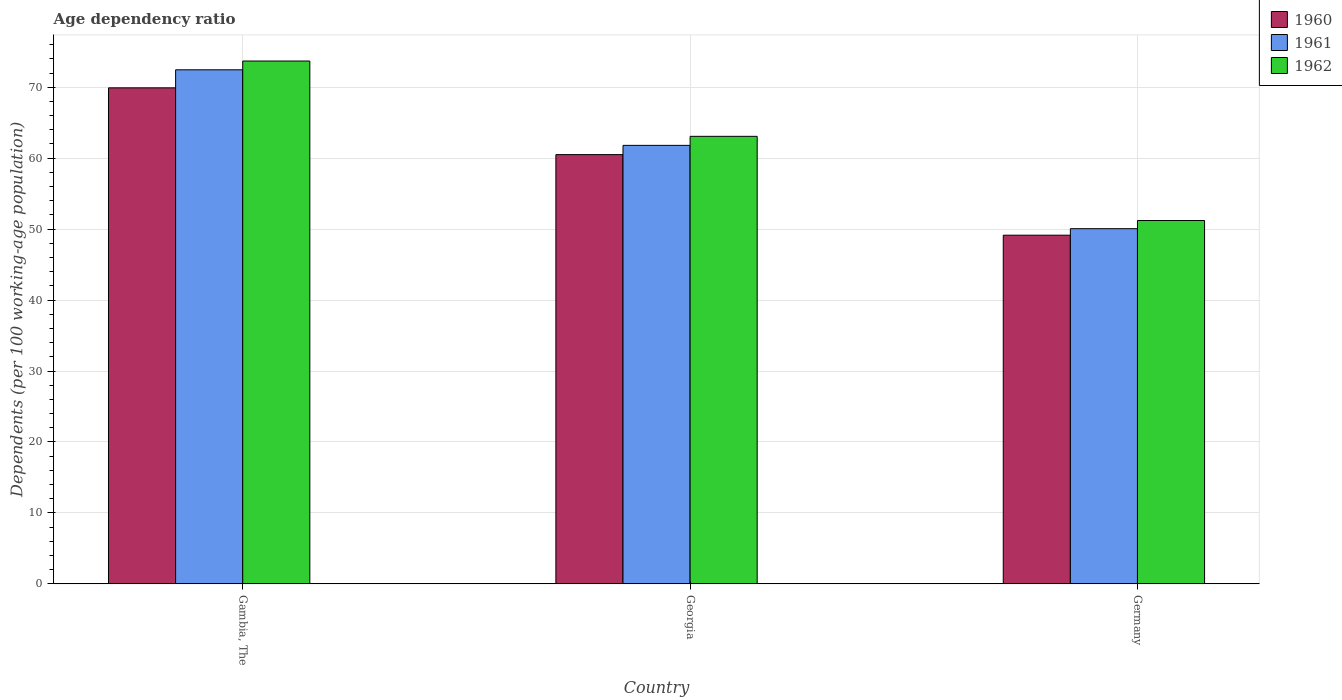How many different coloured bars are there?
Keep it short and to the point. 3. How many groups of bars are there?
Your response must be concise. 3. How many bars are there on the 1st tick from the left?
Your response must be concise. 3. How many bars are there on the 3rd tick from the right?
Give a very brief answer. 3. What is the label of the 1st group of bars from the left?
Provide a short and direct response. Gambia, The. In how many cases, is the number of bars for a given country not equal to the number of legend labels?
Give a very brief answer. 0. What is the age dependency ratio in in 1962 in Gambia, The?
Your answer should be very brief. 73.69. Across all countries, what is the maximum age dependency ratio in in 1960?
Provide a short and direct response. 69.91. Across all countries, what is the minimum age dependency ratio in in 1962?
Your response must be concise. 51.21. In which country was the age dependency ratio in in 1962 maximum?
Your answer should be compact. Gambia, The. In which country was the age dependency ratio in in 1962 minimum?
Provide a short and direct response. Germany. What is the total age dependency ratio in in 1961 in the graph?
Give a very brief answer. 184.31. What is the difference between the age dependency ratio in in 1960 in Gambia, The and that in Germany?
Give a very brief answer. 20.77. What is the difference between the age dependency ratio in in 1961 in Georgia and the age dependency ratio in in 1960 in Germany?
Give a very brief answer. 12.66. What is the average age dependency ratio in in 1962 per country?
Your answer should be compact. 62.66. What is the difference between the age dependency ratio in of/in 1961 and age dependency ratio in of/in 1960 in Georgia?
Keep it short and to the point. 1.3. What is the ratio of the age dependency ratio in in 1962 in Georgia to that in Germany?
Ensure brevity in your answer.  1.23. What is the difference between the highest and the second highest age dependency ratio in in 1962?
Provide a succinct answer. 22.48. What is the difference between the highest and the lowest age dependency ratio in in 1962?
Your answer should be compact. 22.48. In how many countries, is the age dependency ratio in in 1960 greater than the average age dependency ratio in in 1960 taken over all countries?
Make the answer very short. 2. Is the sum of the age dependency ratio in in 1961 in Gambia, The and Georgia greater than the maximum age dependency ratio in in 1962 across all countries?
Your response must be concise. Yes. Is it the case that in every country, the sum of the age dependency ratio in in 1961 and age dependency ratio in in 1962 is greater than the age dependency ratio in in 1960?
Your answer should be very brief. Yes. How many bars are there?
Make the answer very short. 9. Are all the bars in the graph horizontal?
Provide a short and direct response. No. How many countries are there in the graph?
Make the answer very short. 3. Are the values on the major ticks of Y-axis written in scientific E-notation?
Your response must be concise. No. Does the graph contain grids?
Ensure brevity in your answer.  Yes. Where does the legend appear in the graph?
Your answer should be very brief. Top right. How are the legend labels stacked?
Provide a succinct answer. Vertical. What is the title of the graph?
Provide a succinct answer. Age dependency ratio. Does "1992" appear as one of the legend labels in the graph?
Offer a terse response. No. What is the label or title of the Y-axis?
Offer a terse response. Dependents (per 100 working-age population). What is the Dependents (per 100 working-age population) of 1960 in Gambia, The?
Offer a very short reply. 69.91. What is the Dependents (per 100 working-age population) of 1961 in Gambia, The?
Offer a terse response. 72.45. What is the Dependents (per 100 working-age population) of 1962 in Gambia, The?
Your answer should be compact. 73.69. What is the Dependents (per 100 working-age population) in 1960 in Georgia?
Offer a terse response. 60.5. What is the Dependents (per 100 working-age population) in 1961 in Georgia?
Your response must be concise. 61.8. What is the Dependents (per 100 working-age population) in 1962 in Georgia?
Keep it short and to the point. 63.07. What is the Dependents (per 100 working-age population) of 1960 in Germany?
Offer a terse response. 49.14. What is the Dependents (per 100 working-age population) in 1961 in Germany?
Provide a short and direct response. 50.06. What is the Dependents (per 100 working-age population) of 1962 in Germany?
Provide a succinct answer. 51.21. Across all countries, what is the maximum Dependents (per 100 working-age population) in 1960?
Give a very brief answer. 69.91. Across all countries, what is the maximum Dependents (per 100 working-age population) in 1961?
Your answer should be compact. 72.45. Across all countries, what is the maximum Dependents (per 100 working-age population) of 1962?
Ensure brevity in your answer.  73.69. Across all countries, what is the minimum Dependents (per 100 working-age population) of 1960?
Provide a short and direct response. 49.14. Across all countries, what is the minimum Dependents (per 100 working-age population) in 1961?
Offer a terse response. 50.06. Across all countries, what is the minimum Dependents (per 100 working-age population) of 1962?
Offer a very short reply. 51.21. What is the total Dependents (per 100 working-age population) of 1960 in the graph?
Offer a terse response. 179.55. What is the total Dependents (per 100 working-age population) of 1961 in the graph?
Make the answer very short. 184.31. What is the total Dependents (per 100 working-age population) of 1962 in the graph?
Keep it short and to the point. 187.97. What is the difference between the Dependents (per 100 working-age population) in 1960 in Gambia, The and that in Georgia?
Provide a short and direct response. 9.41. What is the difference between the Dependents (per 100 working-age population) in 1961 in Gambia, The and that in Georgia?
Ensure brevity in your answer.  10.65. What is the difference between the Dependents (per 100 working-age population) in 1962 in Gambia, The and that in Georgia?
Offer a terse response. 10.62. What is the difference between the Dependents (per 100 working-age population) in 1960 in Gambia, The and that in Germany?
Provide a succinct answer. 20.77. What is the difference between the Dependents (per 100 working-age population) in 1961 in Gambia, The and that in Germany?
Your answer should be very brief. 22.39. What is the difference between the Dependents (per 100 working-age population) of 1962 in Gambia, The and that in Germany?
Make the answer very short. 22.48. What is the difference between the Dependents (per 100 working-age population) in 1960 in Georgia and that in Germany?
Provide a short and direct response. 11.36. What is the difference between the Dependents (per 100 working-age population) of 1961 in Georgia and that in Germany?
Offer a very short reply. 11.74. What is the difference between the Dependents (per 100 working-age population) of 1962 in Georgia and that in Germany?
Offer a terse response. 11.86. What is the difference between the Dependents (per 100 working-age population) in 1960 in Gambia, The and the Dependents (per 100 working-age population) in 1961 in Georgia?
Offer a very short reply. 8.11. What is the difference between the Dependents (per 100 working-age population) in 1960 in Gambia, The and the Dependents (per 100 working-age population) in 1962 in Georgia?
Your response must be concise. 6.83. What is the difference between the Dependents (per 100 working-age population) in 1961 in Gambia, The and the Dependents (per 100 working-age population) in 1962 in Georgia?
Keep it short and to the point. 9.38. What is the difference between the Dependents (per 100 working-age population) in 1960 in Gambia, The and the Dependents (per 100 working-age population) in 1961 in Germany?
Provide a short and direct response. 19.85. What is the difference between the Dependents (per 100 working-age population) in 1960 in Gambia, The and the Dependents (per 100 working-age population) in 1962 in Germany?
Provide a short and direct response. 18.7. What is the difference between the Dependents (per 100 working-age population) in 1961 in Gambia, The and the Dependents (per 100 working-age population) in 1962 in Germany?
Make the answer very short. 21.24. What is the difference between the Dependents (per 100 working-age population) of 1960 in Georgia and the Dependents (per 100 working-age population) of 1961 in Germany?
Your response must be concise. 10.44. What is the difference between the Dependents (per 100 working-age population) in 1960 in Georgia and the Dependents (per 100 working-age population) in 1962 in Germany?
Your response must be concise. 9.29. What is the difference between the Dependents (per 100 working-age population) in 1961 in Georgia and the Dependents (per 100 working-age population) in 1962 in Germany?
Provide a short and direct response. 10.59. What is the average Dependents (per 100 working-age population) of 1960 per country?
Provide a short and direct response. 59.85. What is the average Dependents (per 100 working-age population) of 1961 per country?
Provide a short and direct response. 61.44. What is the average Dependents (per 100 working-age population) of 1962 per country?
Give a very brief answer. 62.66. What is the difference between the Dependents (per 100 working-age population) of 1960 and Dependents (per 100 working-age population) of 1961 in Gambia, The?
Your answer should be very brief. -2.54. What is the difference between the Dependents (per 100 working-age population) in 1960 and Dependents (per 100 working-age population) in 1962 in Gambia, The?
Offer a terse response. -3.78. What is the difference between the Dependents (per 100 working-age population) in 1961 and Dependents (per 100 working-age population) in 1962 in Gambia, The?
Make the answer very short. -1.24. What is the difference between the Dependents (per 100 working-age population) of 1960 and Dependents (per 100 working-age population) of 1961 in Georgia?
Provide a short and direct response. -1.3. What is the difference between the Dependents (per 100 working-age population) in 1960 and Dependents (per 100 working-age population) in 1962 in Georgia?
Make the answer very short. -2.58. What is the difference between the Dependents (per 100 working-age population) in 1961 and Dependents (per 100 working-age population) in 1962 in Georgia?
Keep it short and to the point. -1.27. What is the difference between the Dependents (per 100 working-age population) of 1960 and Dependents (per 100 working-age population) of 1961 in Germany?
Offer a very short reply. -0.92. What is the difference between the Dependents (per 100 working-age population) in 1960 and Dependents (per 100 working-age population) in 1962 in Germany?
Your response must be concise. -2.07. What is the difference between the Dependents (per 100 working-age population) in 1961 and Dependents (per 100 working-age population) in 1962 in Germany?
Provide a succinct answer. -1.15. What is the ratio of the Dependents (per 100 working-age population) of 1960 in Gambia, The to that in Georgia?
Provide a succinct answer. 1.16. What is the ratio of the Dependents (per 100 working-age population) in 1961 in Gambia, The to that in Georgia?
Your answer should be very brief. 1.17. What is the ratio of the Dependents (per 100 working-age population) of 1962 in Gambia, The to that in Georgia?
Give a very brief answer. 1.17. What is the ratio of the Dependents (per 100 working-age population) in 1960 in Gambia, The to that in Germany?
Give a very brief answer. 1.42. What is the ratio of the Dependents (per 100 working-age population) of 1961 in Gambia, The to that in Germany?
Offer a terse response. 1.45. What is the ratio of the Dependents (per 100 working-age population) in 1962 in Gambia, The to that in Germany?
Your answer should be compact. 1.44. What is the ratio of the Dependents (per 100 working-age population) of 1960 in Georgia to that in Germany?
Your response must be concise. 1.23. What is the ratio of the Dependents (per 100 working-age population) in 1961 in Georgia to that in Germany?
Give a very brief answer. 1.23. What is the ratio of the Dependents (per 100 working-age population) in 1962 in Georgia to that in Germany?
Provide a succinct answer. 1.23. What is the difference between the highest and the second highest Dependents (per 100 working-age population) in 1960?
Provide a succinct answer. 9.41. What is the difference between the highest and the second highest Dependents (per 100 working-age population) in 1961?
Ensure brevity in your answer.  10.65. What is the difference between the highest and the second highest Dependents (per 100 working-age population) of 1962?
Your response must be concise. 10.62. What is the difference between the highest and the lowest Dependents (per 100 working-age population) in 1960?
Ensure brevity in your answer.  20.77. What is the difference between the highest and the lowest Dependents (per 100 working-age population) of 1961?
Offer a terse response. 22.39. What is the difference between the highest and the lowest Dependents (per 100 working-age population) of 1962?
Ensure brevity in your answer.  22.48. 